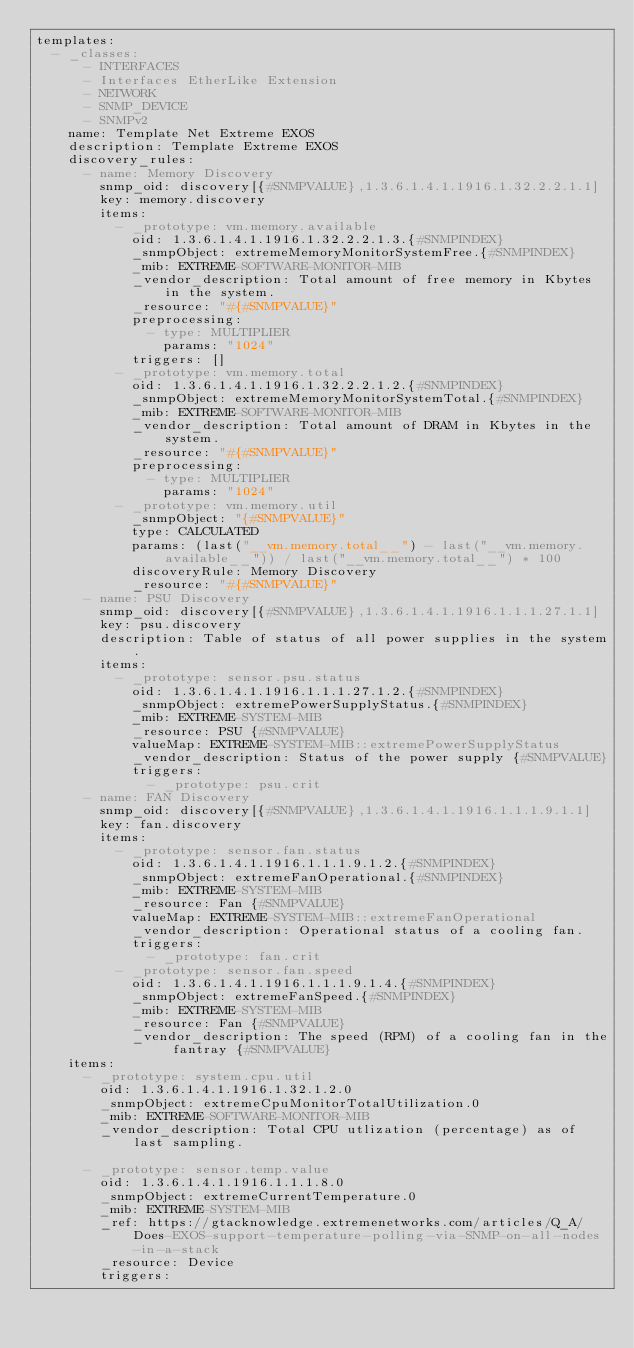Convert code to text. <code><loc_0><loc_0><loc_500><loc_500><_YAML_>templates:
  - _classes:
      - INTERFACES
      - Interfaces EtherLike Extension
      - NETWORK
      - SNMP_DEVICE
      - SNMPv2
    name: Template Net Extreme EXOS
    description: Template Extreme EXOS
    discovery_rules:
      - name: Memory Discovery
        snmp_oid: discovery[{#SNMPVALUE},1.3.6.1.4.1.1916.1.32.2.2.1.1]
        key: memory.discovery
        items:
          - _prototype: vm.memory.available
            oid: 1.3.6.1.4.1.1916.1.32.2.2.1.3.{#SNMPINDEX}
            _snmpObject: extremeMemoryMonitorSystemFree.{#SNMPINDEX}
            _mib: EXTREME-SOFTWARE-MONITOR-MIB
            _vendor_description: Total amount of free memory in Kbytes in the system.
            _resource: "#{#SNMPVALUE}"
            preprocessing:
              - type: MULTIPLIER
                params: "1024"
            triggers: []
          - _prototype: vm.memory.total
            oid: 1.3.6.1.4.1.1916.1.32.2.2.1.2.{#SNMPINDEX}
            _snmpObject: extremeMemoryMonitorSystemTotal.{#SNMPINDEX}
            _mib: EXTREME-SOFTWARE-MONITOR-MIB
            _vendor_description: Total amount of DRAM in Kbytes in the system.
            _resource: "#{#SNMPVALUE}"
            preprocessing:
              - type: MULTIPLIER
                params: "1024"
          - _prototype: vm.memory.util
            _snmpObject: "{#SNMPVALUE}"
            type: CALCULATED
            params: (last("__vm.memory.total__") - last("__vm.memory.available__")) / last("__vm.memory.total__") * 100
            discoveryRule: Memory Discovery
            _resource: "#{#SNMPVALUE}"
      - name: PSU Discovery
        snmp_oid: discovery[{#SNMPVALUE},1.3.6.1.4.1.1916.1.1.1.27.1.1]
        key: psu.discovery
        description: Table of status of all power supplies in the system.
        items:
          - _prototype: sensor.psu.status
            oid: 1.3.6.1.4.1.1916.1.1.1.27.1.2.{#SNMPINDEX}
            _snmpObject: extremePowerSupplyStatus.{#SNMPINDEX}
            _mib: EXTREME-SYSTEM-MIB
            _resource: PSU {#SNMPVALUE}
            valueMap: EXTREME-SYSTEM-MIB::extremePowerSupplyStatus
            _vendor_description: Status of the power supply {#SNMPVALUE}
            triggers:
              - _prototype: psu.crit
      - name: FAN Discovery
        snmp_oid: discovery[{#SNMPVALUE},1.3.6.1.4.1.1916.1.1.1.9.1.1]
        key: fan.discovery
        items:
          - _prototype: sensor.fan.status
            oid: 1.3.6.1.4.1.1916.1.1.1.9.1.2.{#SNMPINDEX}
            _snmpObject: extremeFanOperational.{#SNMPINDEX}
            _mib: EXTREME-SYSTEM-MIB
            _resource: Fan {#SNMPVALUE}
            valueMap: EXTREME-SYSTEM-MIB::extremeFanOperational
            _vendor_description: Operational status of a cooling fan.
            triggers:
              - _prototype: fan.crit
          - _prototype: sensor.fan.speed
            oid: 1.3.6.1.4.1.1916.1.1.1.9.1.4.{#SNMPINDEX}
            _snmpObject: extremeFanSpeed.{#SNMPINDEX}
            _mib: EXTREME-SYSTEM-MIB
            _resource: Fan {#SNMPVALUE}
            _vendor_description: The speed (RPM) of a cooling fan in the fantray {#SNMPVALUE}
    items:
      - _prototype: system.cpu.util
        oid: 1.3.6.1.4.1.1916.1.32.1.2.0
        _snmpObject: extremeCpuMonitorTotalUtilization.0
        _mib: EXTREME-SOFTWARE-MONITOR-MIB
        _vendor_description: Total CPU utlization (percentage) as of last sampling.

      - _prototype: sensor.temp.value
        oid: 1.3.6.1.4.1.1916.1.1.1.8.0
        _snmpObject: extremeCurrentTemperature.0
        _mib: EXTREME-SYSTEM-MIB
        _ref: https://gtacknowledge.extremenetworks.com/articles/Q_A/Does-EXOS-support-temperature-polling-via-SNMP-on-all-nodes-in-a-stack
        _resource: Device
        triggers:</code> 